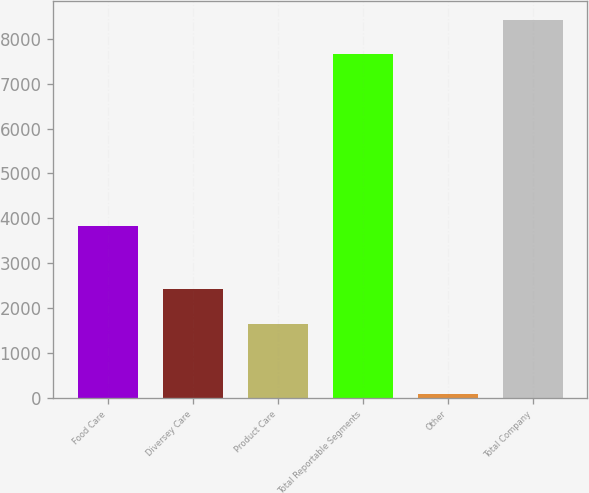Convert chart to OTSL. <chart><loc_0><loc_0><loc_500><loc_500><bar_chart><fcel>Food Care<fcel>Diversey Care<fcel>Product Care<fcel>Total Reportable Segments<fcel>Other<fcel>Total Company<nl><fcel>3835.3<fcel>2421.34<fcel>1655<fcel>7663.4<fcel>87.1<fcel>8429.74<nl></chart> 